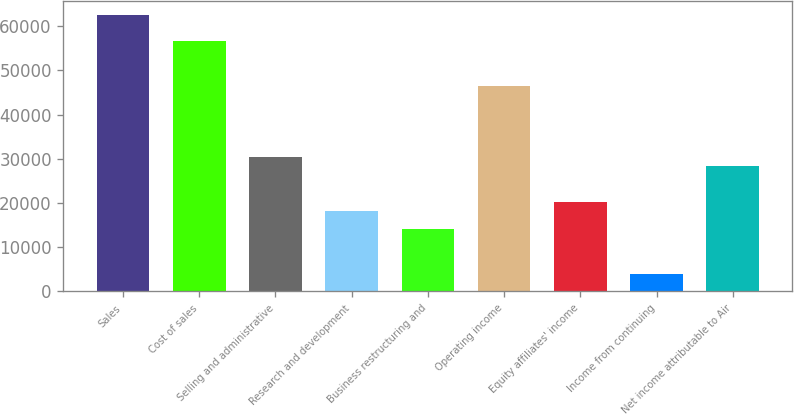<chart> <loc_0><loc_0><loc_500><loc_500><bar_chart><fcel>Sales<fcel>Cost of sales<fcel>Selling and administrative<fcel>Research and development<fcel>Business restructuring and<fcel>Operating income<fcel>Equity affiliates' income<fcel>Income from continuing<fcel>Net income attributable to Air<nl><fcel>62582.9<fcel>56526.8<fcel>30283.6<fcel>18171.3<fcel>14133.9<fcel>46433.2<fcel>20190<fcel>4040.34<fcel>28264.9<nl></chart> 